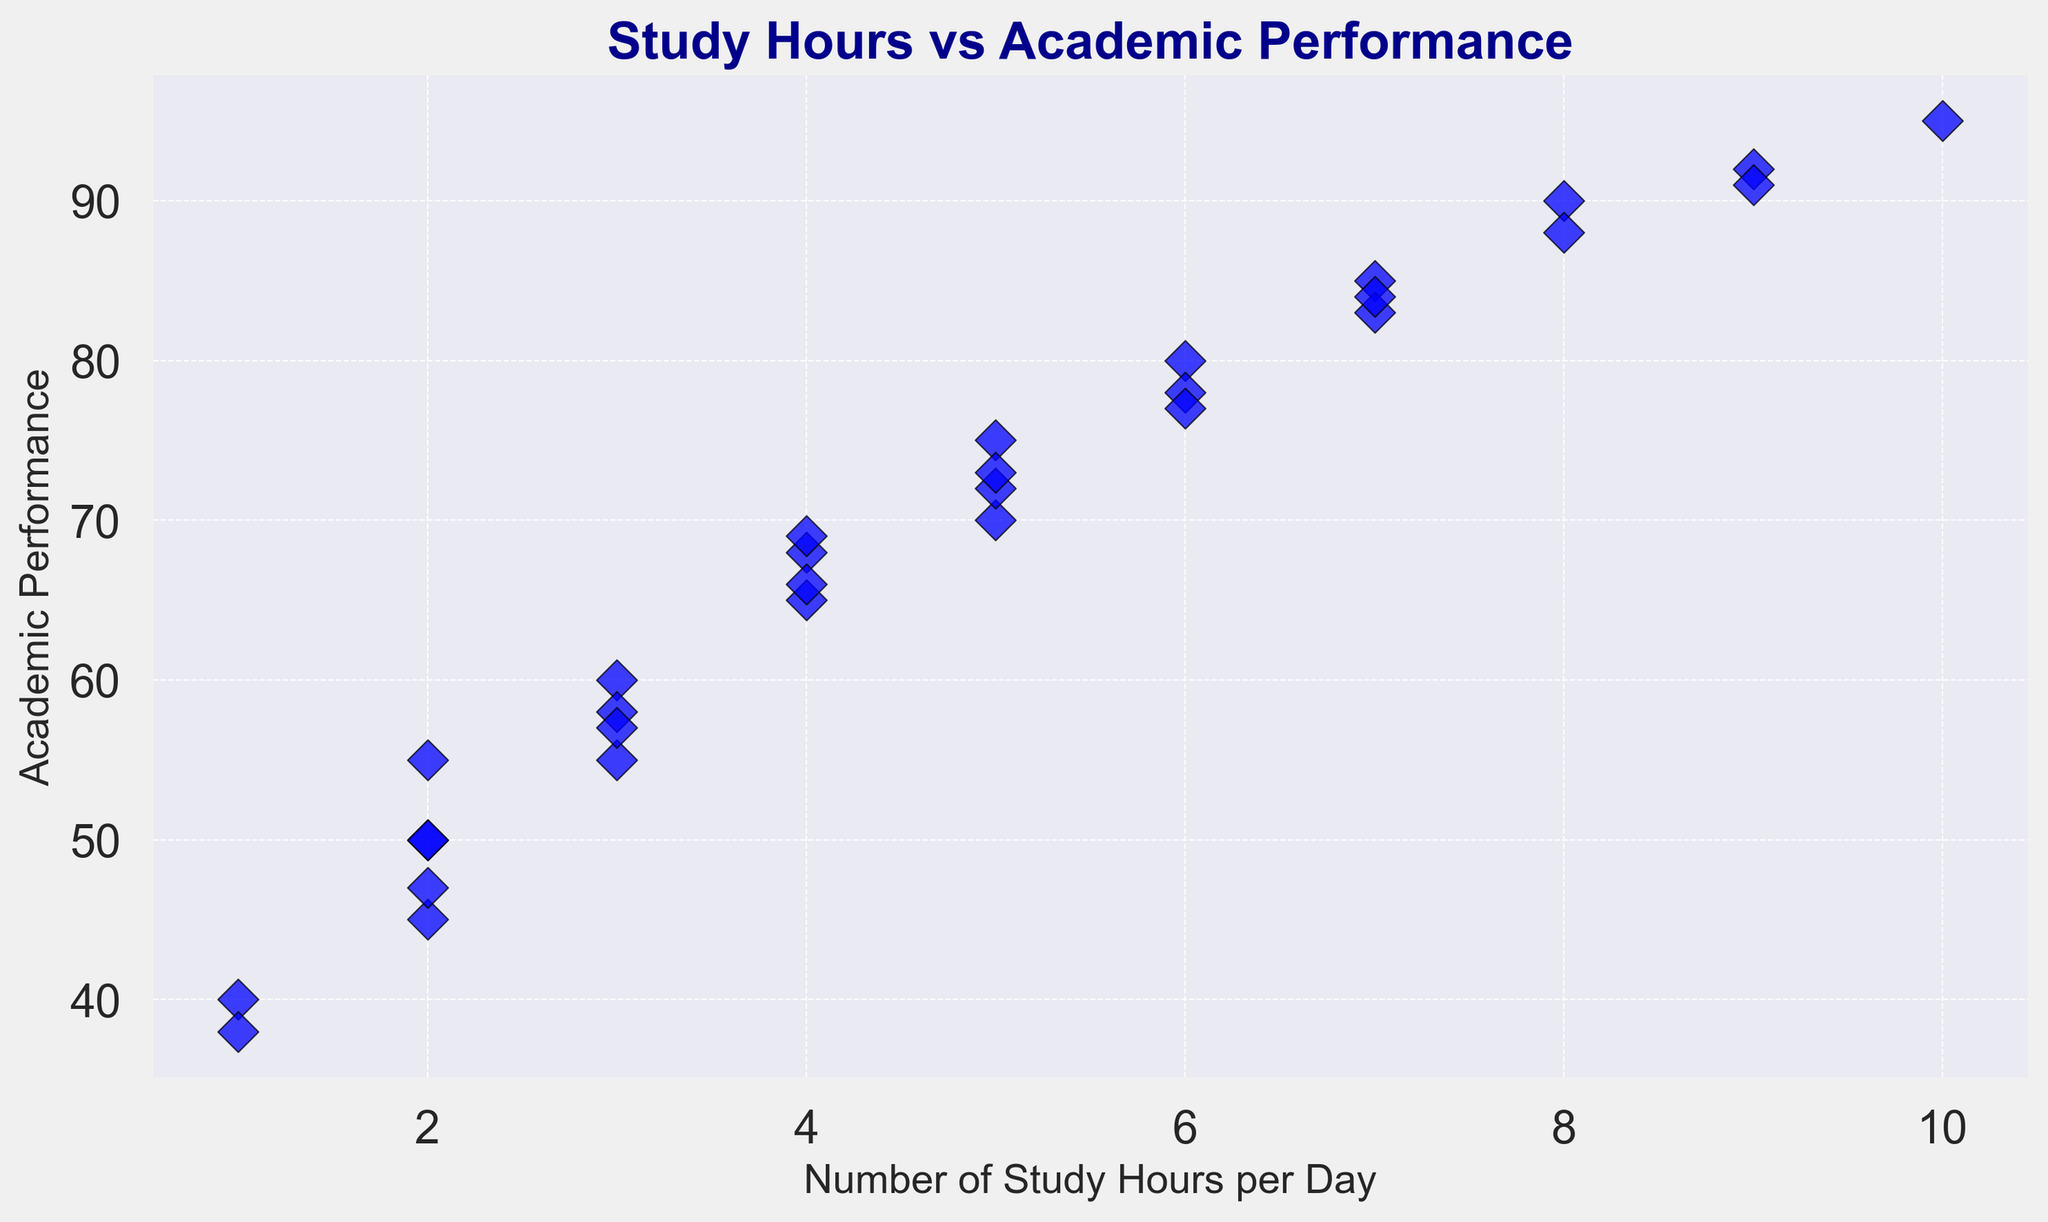How many students studied for 6 hours? To determine the number of students who studied for 6 hours, count the number of data points where the x-value (Number of Study Hours per Day) is exactly 6.
Answer: 2 What is the highest academic performance recorded, and how many study hours were associated with it? Look at the y-axis to find the highest point on the plot, which represents the maximum academic performance. Then, check the corresponding x-value for the number of study hours.
Answer: 95, 10 hours Compare the academic performance of students who studied 3 hours and 4 hours. Which group performed better on average? Identify the y-values for students who studied exactly 3 hours (55, 60, 58, 57) and 4 hours (65, 68, 66, 69). Calculate the average for each group and compare the two. Average for 3 hours: (55 + 60 + 58 + 57)/4 = 57.5, Average for 4 hours: (65 + 68 + 66 + 69)/4 = 67.
Answer: Students who studied 4 hours performed better on average How many students have an academic performance of 70 or above? Count the number of data points where the y-value (Academic Performance) is 70 or higher.
Answer: 10 What is the median number of study hours among the students? Arrange the study hours in ascending order: 1, 1, 2, 2, 2, 2, 3, 3, 3, 3, 4, 4, 4, 5, 5, 5, 6, 6, 6, 7, 7, 8, 8, 9, 9, 10. The median is the middle value, which is between the 15th and 16th values: (5 + 5)/2 = 5.
Answer: 5 Is there a general trend between study hours and academic performance? Observe the overall pattern of the scatter plot. If the points generally slope upwards as the study hours increase, it indicates a positive correlation.
Answer: Yes, there is a positive correlation Which student(s) had the lowest academic performance, and how many hours did they study? Identify the lowest y-value on the plot and check the corresponding x-value for study hours. The lowest academic performance is 38.
Answer: 38, 1 hour What is the total academic performance for students who studied 5 hours? Identify the data points where students studied 5 hours and sum their y-values: 70, 75, 72, 73. Total performance = 70 + 75 + 72 + 73 = 290.
Answer: 290 